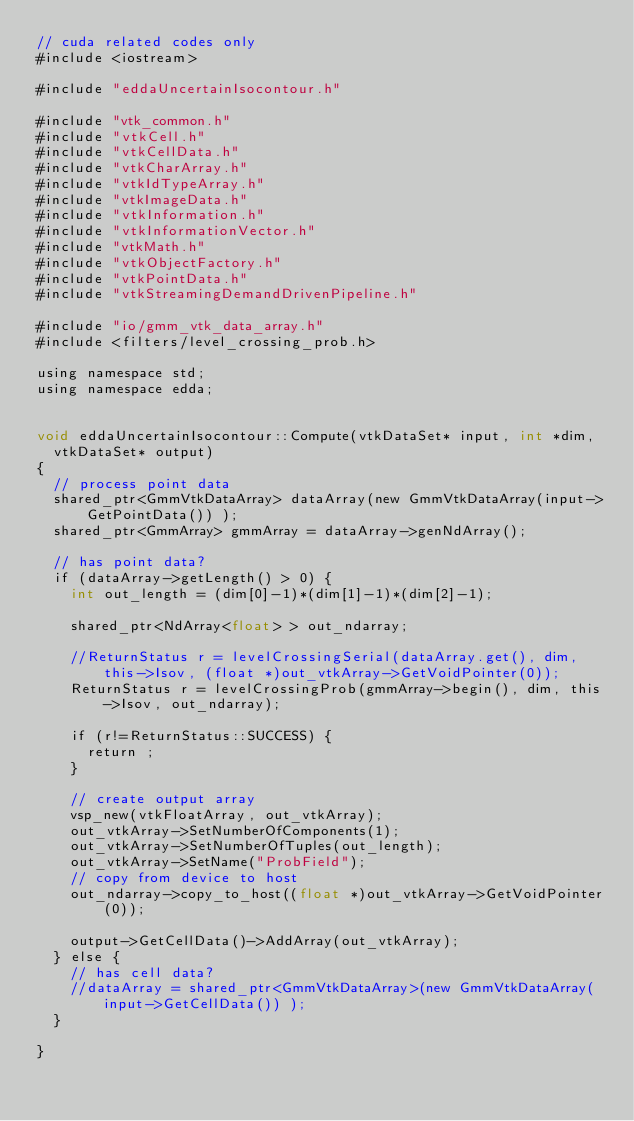Convert code to text. <code><loc_0><loc_0><loc_500><loc_500><_Cuda_>// cuda related codes only
#include <iostream>

#include "eddaUncertainIsocontour.h"

#include "vtk_common.h"
#include "vtkCell.h"
#include "vtkCellData.h"
#include "vtkCharArray.h"
#include "vtkIdTypeArray.h"
#include "vtkImageData.h"
#include "vtkInformation.h"
#include "vtkInformationVector.h"
#include "vtkMath.h"
#include "vtkObjectFactory.h"
#include "vtkPointData.h"
#include "vtkStreamingDemandDrivenPipeline.h"

#include "io/gmm_vtk_data_array.h"
#include <filters/level_crossing_prob.h>

using namespace std;
using namespace edda;


void eddaUncertainIsocontour::Compute(vtkDataSet* input, int *dim,
  vtkDataSet* output)
{
  // process point data
  shared_ptr<GmmVtkDataArray> dataArray(new GmmVtkDataArray(input->GetPointData()) );
  shared_ptr<GmmArray> gmmArray = dataArray->genNdArray();

  // has point data?
  if (dataArray->getLength() > 0) {
    int out_length = (dim[0]-1)*(dim[1]-1)*(dim[2]-1);

    shared_ptr<NdArray<float> > out_ndarray;

    //ReturnStatus r = levelCrossingSerial(dataArray.get(), dim, this->Isov, (float *)out_vtkArray->GetVoidPointer(0));
    ReturnStatus r = levelCrossingProb(gmmArray->begin(), dim, this->Isov, out_ndarray);

    if (r!=ReturnStatus::SUCCESS) {
      return ;
    }

    // create output array
    vsp_new(vtkFloatArray, out_vtkArray);
    out_vtkArray->SetNumberOfComponents(1);
    out_vtkArray->SetNumberOfTuples(out_length);
    out_vtkArray->SetName("ProbField");
    // copy from device to host
    out_ndarray->copy_to_host((float *)out_vtkArray->GetVoidPointer(0));

    output->GetCellData()->AddArray(out_vtkArray);
  } else {
    // has cell data?
    //dataArray = shared_ptr<GmmVtkDataArray>(new GmmVtkDataArray(input->GetCellData()) );
  }

}
</code> 